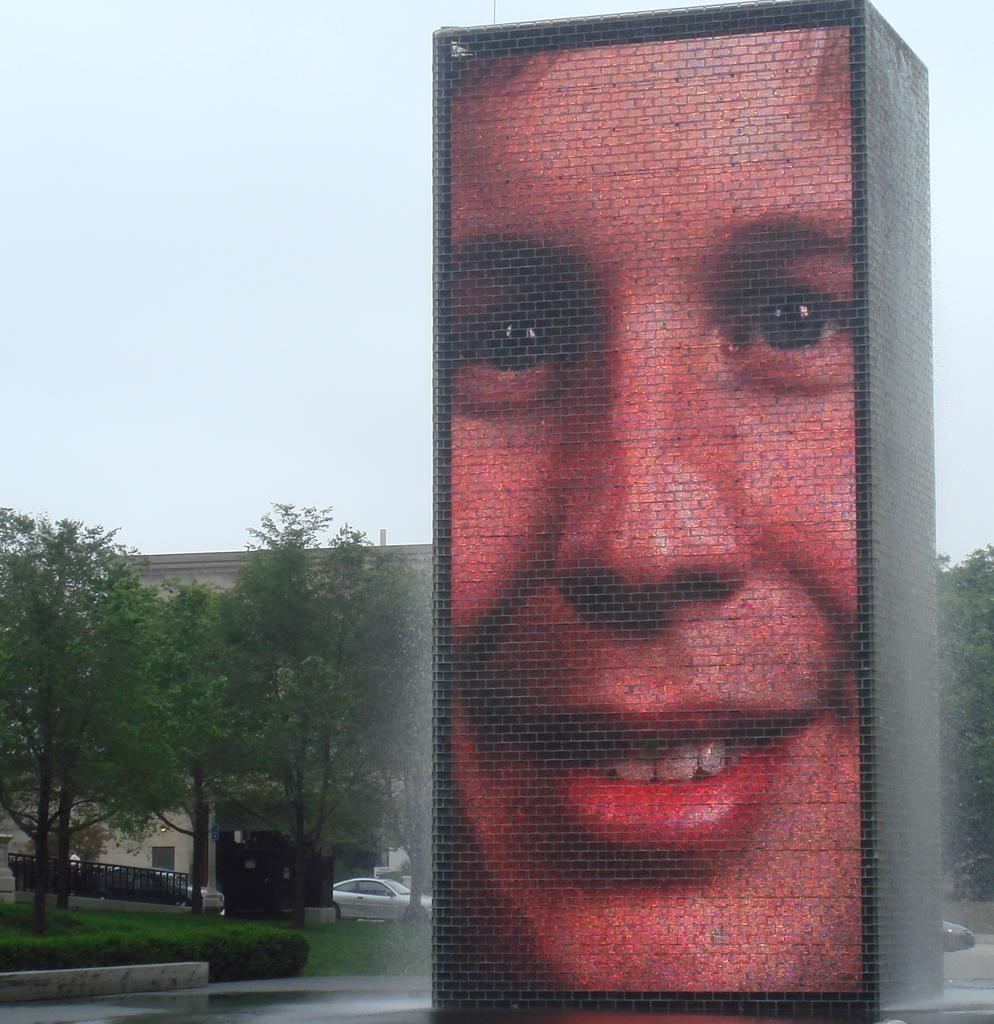Who or what is the main subject in the image? There is a person in the image. What is the person doing in the image? The person is sitting on a block. What can be seen behind the block? There are trees behind the block. What architectural features are visible in the image? There is a fence and buildings in the background. What type of vehicles can be seen in the background? There are cars in the background. What is the condition of the ground in the image? There is water on the ground. What time of day is it in the image, considering the presence of stars? There are no stars visible in the image, so it is not possible to determine the time of day based on that information. 